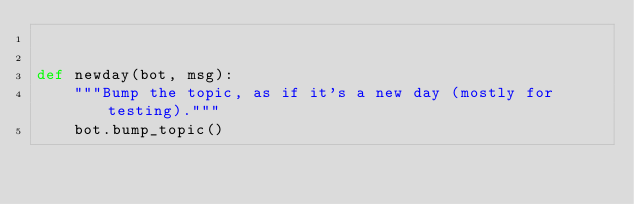<code> <loc_0><loc_0><loc_500><loc_500><_Python_>

def newday(bot, msg):
    """Bump the topic, as if it's a new day (mostly for testing)."""
    bot.bump_topic()
</code> 